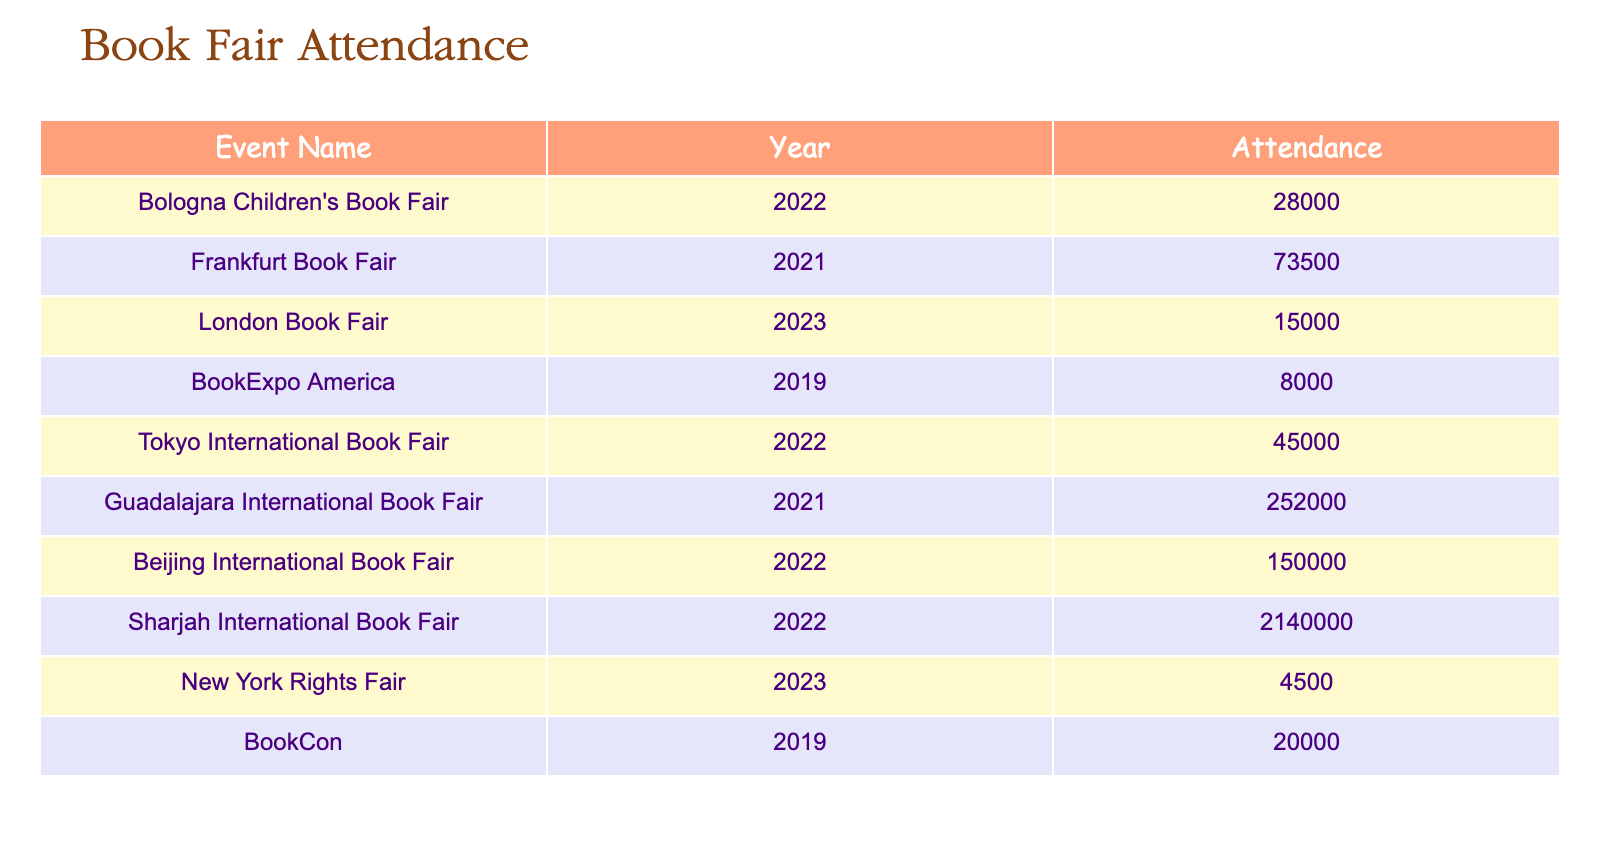What is the attendance number for the Bologna Children's Book Fair in 2022? The table shows a row for the Bologna Children's Book Fair, listing its attendance for the year 2022 as 28000.
Answer: 28000 Which book fair had the highest attendance, and what was that number? By examining the attendance numbers for all events in the table, the Sharjah International Book Fair in 2022 has the highest attendance of 2140000.
Answer: 2140000 How many attendees were at the London Book Fair in 2023? Looking at the row for the London Book Fair, it shows an attendance of 15000 for the year 2023.
Answer: 15000 What is the total attendance for events in 2021? The events in 2021 are the Frankfurt Book Fair with 73500 and the Guadalajara International Book Fair with 252000. Summing these gives 73500 + 252000 = 325500.
Answer: 325500 Is the attendance for BookCon in 2019 greater than that of the New York Rights Fair in 2023? From the table, BookCon in 2019 has an attendance of 20000, while the New York Rights Fair in 2023 has an attendance of 4500. Since 20000 is greater than 4500, the statement is true.
Answer: Yes What is the difference in attendance between the Tokyo International Book Fair in 2022 and the London Book Fair in 2023? The Tokyo International Book Fair in 2022 has an attendance of 45000, while the London Book Fair in 2023 has 15000. The difference is 45000 - 15000 = 30000.
Answer: 30000 What was the attendance for the Beijing International Book Fair in 2022? The table indicates that the Beijing International Book Fair in 2022 had an attendance of 150000.
Answer: 150000 How many more attendees were at the Guadalajara International Book Fair in 2021 compared to the BookExpo America in 2019? The Guadalajara International Book Fair had an attendance of 252000, and the BookExpo America had 8000. The difference is 252000 - 8000 = 244000.
Answer: 244000 Did the Frankfurt Book Fair have more attendees than the Sharjah International Book Fair? The Frankfurt Book Fair has an attendance of 73500, while the Sharjah International Book Fair has 2140000. Since 73500 is much less than 2140000, this statement is false.
Answer: No 